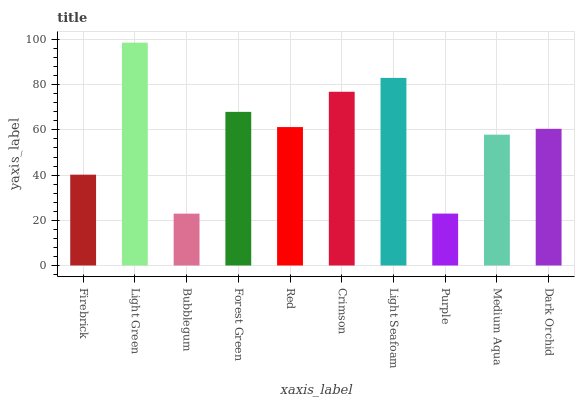Is Bubblegum the minimum?
Answer yes or no. Yes. Is Light Green the maximum?
Answer yes or no. Yes. Is Light Green the minimum?
Answer yes or no. No. Is Bubblegum the maximum?
Answer yes or no. No. Is Light Green greater than Bubblegum?
Answer yes or no. Yes. Is Bubblegum less than Light Green?
Answer yes or no. Yes. Is Bubblegum greater than Light Green?
Answer yes or no. No. Is Light Green less than Bubblegum?
Answer yes or no. No. Is Red the high median?
Answer yes or no. Yes. Is Dark Orchid the low median?
Answer yes or no. Yes. Is Light Green the high median?
Answer yes or no. No. Is Crimson the low median?
Answer yes or no. No. 